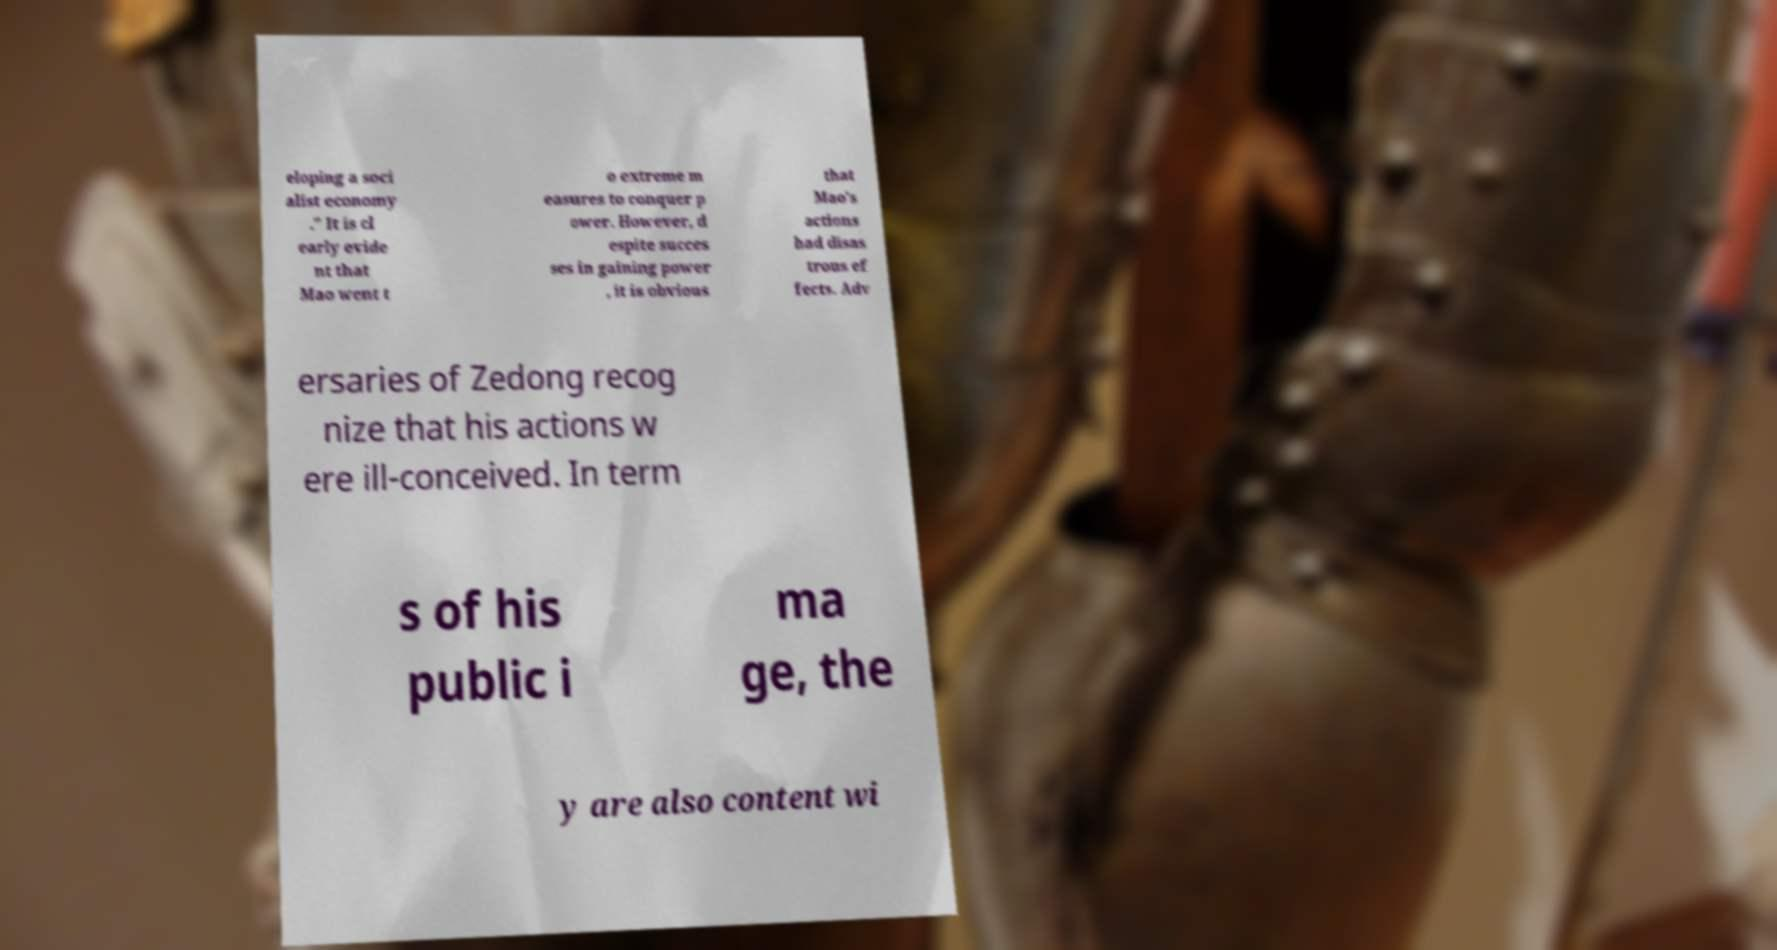I need the written content from this picture converted into text. Can you do that? eloping a soci alist economy ." It is cl early evide nt that Mao went t o extreme m easures to conquer p ower. However, d espite succes ses in gaining power , it is obvious that Mao's actions had disas trous ef fects. Adv ersaries of Zedong recog nize that his actions w ere ill-conceived. In term s of his public i ma ge, the y are also content wi 